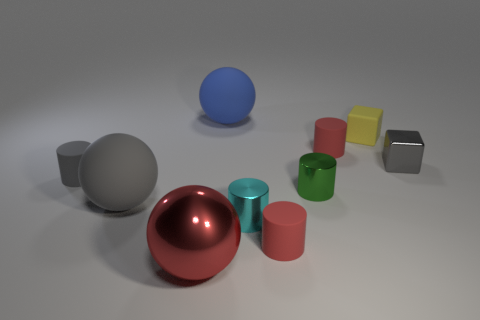Are there any other tiny red things of the same shape as the red metal object?
Provide a short and direct response. No. There is a yellow thing; is its shape the same as the tiny gray thing that is left of the metallic cube?
Offer a terse response. No. What number of spheres are either tiny cyan objects or small green shiny things?
Your response must be concise. 0. What is the shape of the tiny red thing behind the gray rubber ball?
Offer a terse response. Cylinder. What number of large balls have the same material as the small yellow object?
Ensure brevity in your answer.  2. Are there fewer cyan objects behind the blue matte ball than tiny purple metallic objects?
Offer a terse response. No. There is a red matte cylinder in front of the red matte thing behind the small metal cube; what size is it?
Offer a terse response. Small. There is a large shiny sphere; does it have the same color as the tiny rubber cylinder in front of the gray matte cylinder?
Provide a succinct answer. Yes. There is a gray sphere that is the same size as the blue rubber thing; what material is it?
Offer a very short reply. Rubber. Are there fewer matte cylinders that are in front of the green thing than big metal balls behind the small cyan metal cylinder?
Give a very brief answer. No. 